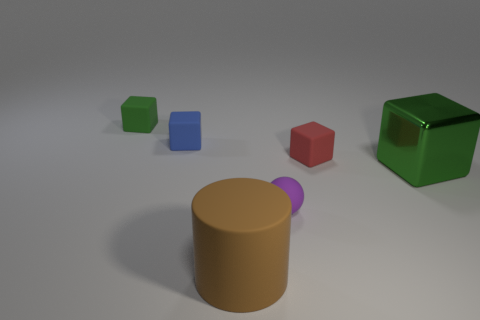The rubber thing that is both to the right of the large brown matte cylinder and behind the metal cube is what color?
Offer a terse response. Red. What number of objects are either cubes on the left side of the big brown thing or tiny cubes that are on the right side of the rubber ball?
Provide a short and direct response. 3. There is a big shiny block right of the tiny rubber object in front of the green thing that is right of the brown rubber cylinder; what is its color?
Your answer should be compact. Green. Is there a large green metal thing of the same shape as the tiny green matte thing?
Provide a short and direct response. Yes. What number of tiny red things are there?
Provide a short and direct response. 1. What shape is the tiny green thing?
Your answer should be very brief. Cube. What number of cubes are the same size as the rubber ball?
Give a very brief answer. 3. Is the red rubber object the same shape as the brown thing?
Give a very brief answer. No. There is a small block that is on the right side of the large thing in front of the large green cube; what color is it?
Your answer should be very brief. Red. How big is the object that is both in front of the small red block and behind the rubber ball?
Your answer should be very brief. Large. 